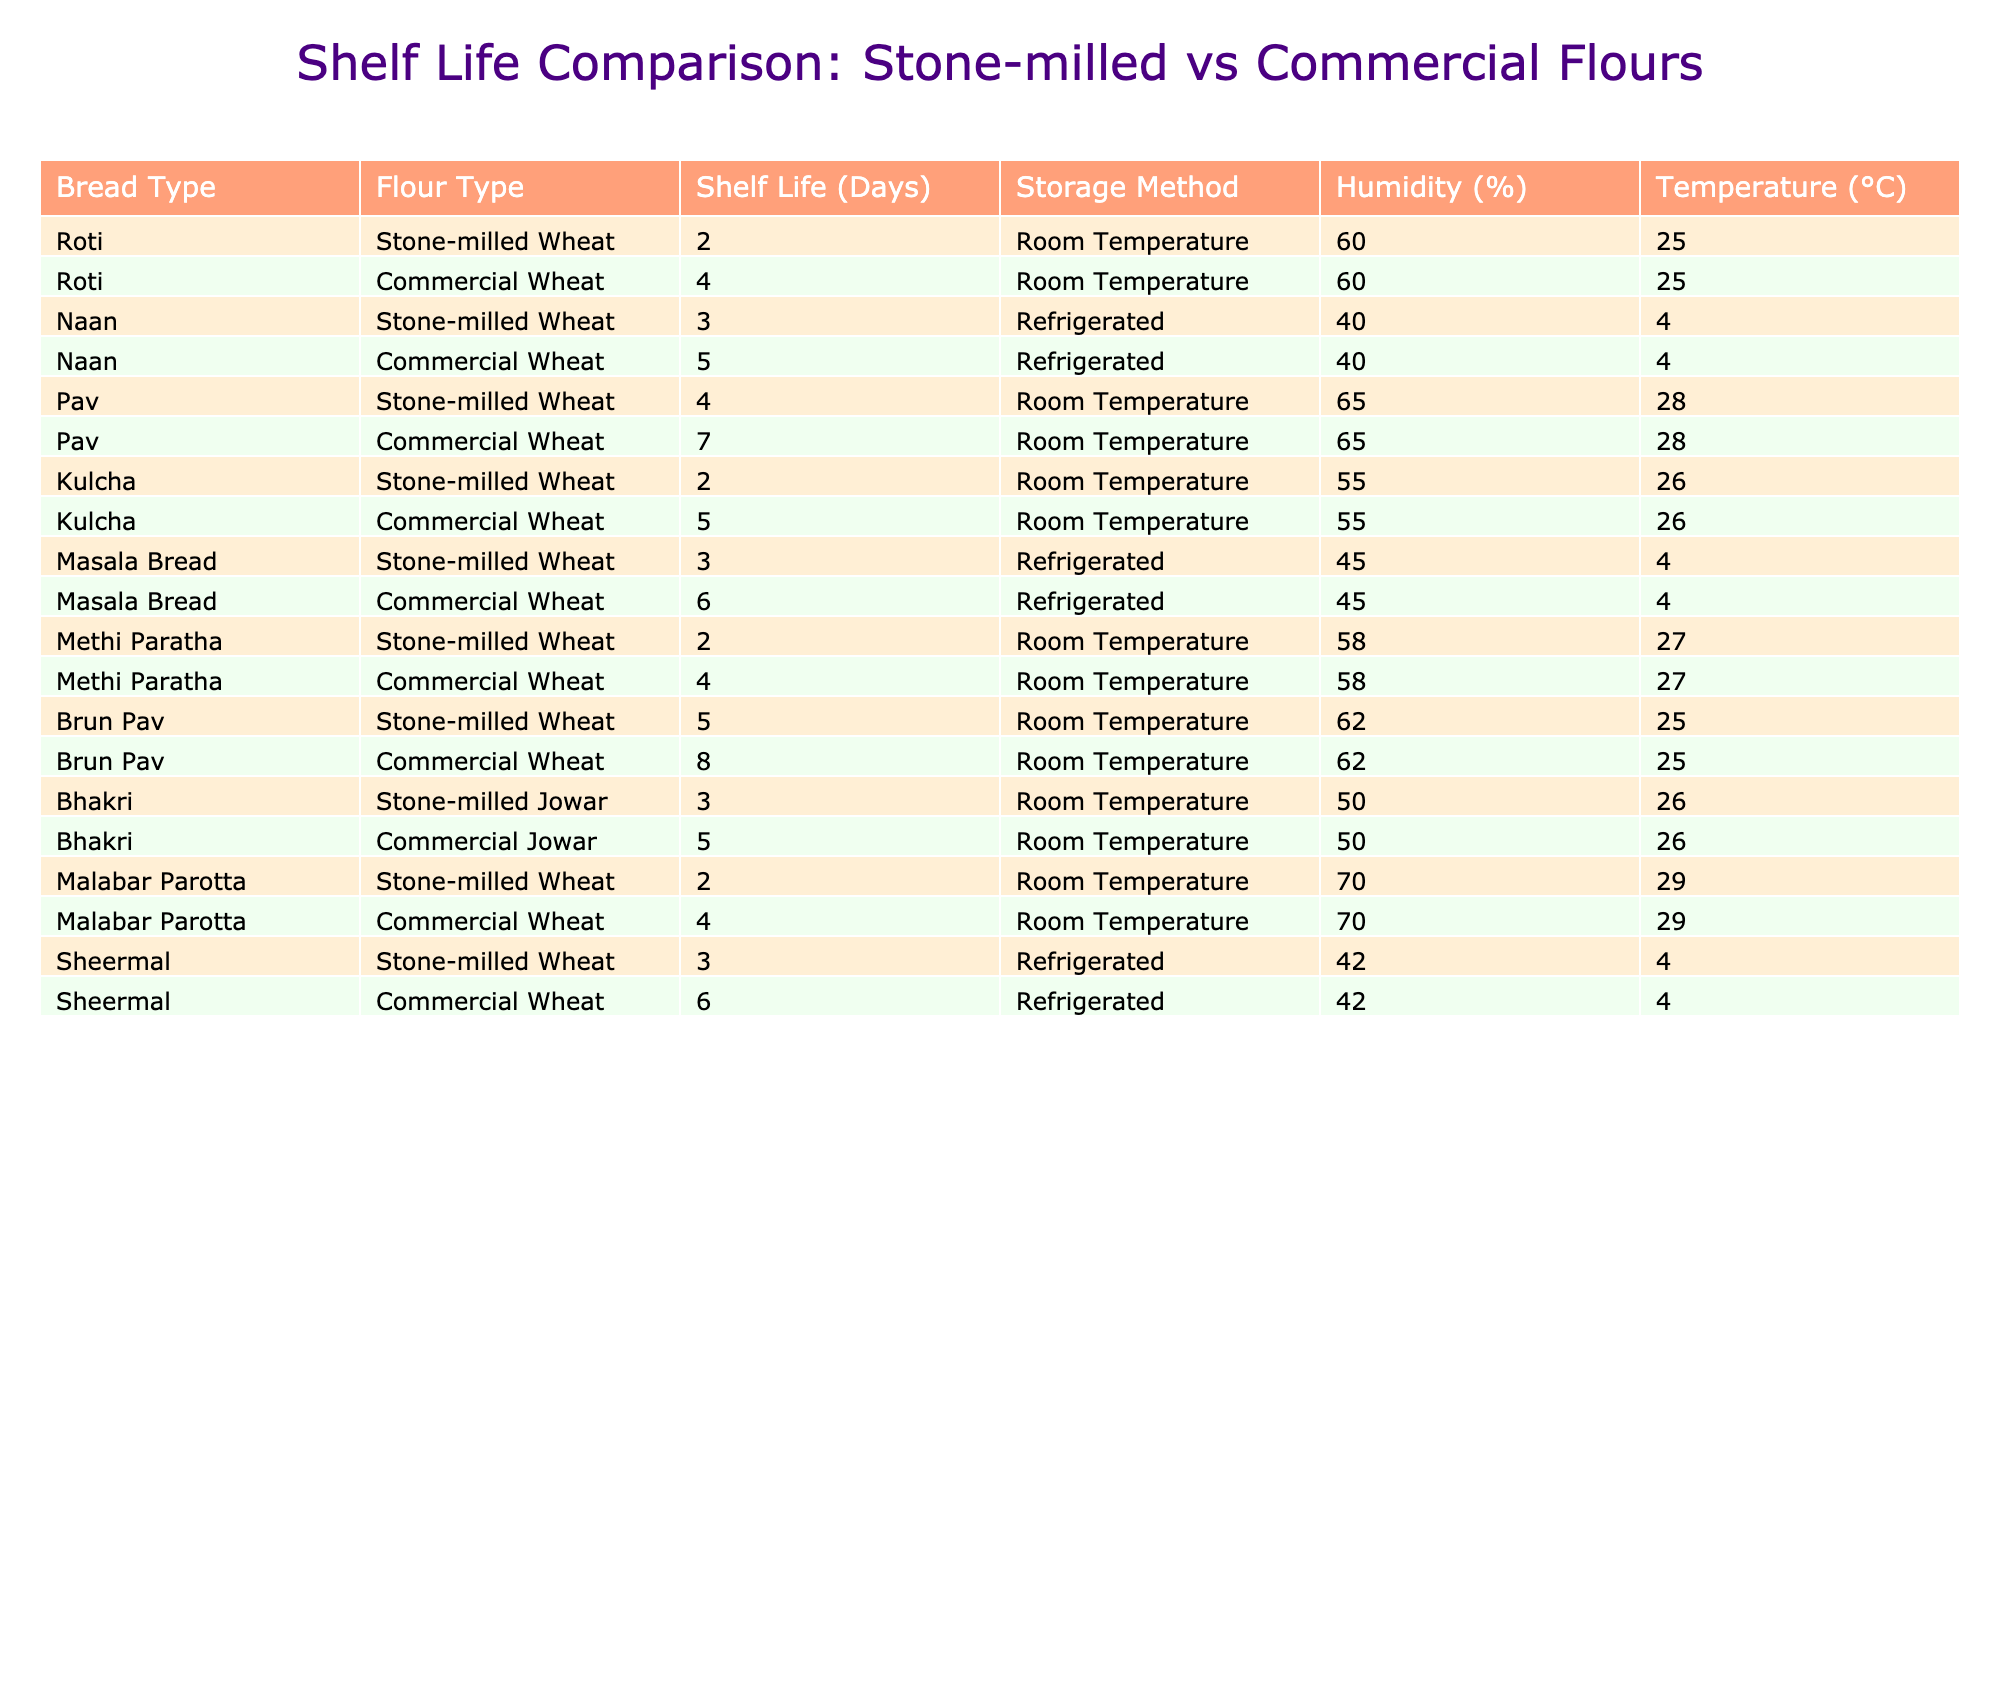What is the shelf life of Roti made with stone-milled flour? From the table, the shelf life of Roti made with stone-milled flour is listed as 2 days.
Answer: 2 days What is the shelf life difference for Naan made with stone-milled vs commercial flour? The shelf life of Naan made with stone-milled flour is 3 days, while for commercial flour, it is 5 days. The difference is 5 - 3 = 2 days.
Answer: 2 days Is the shelf life of Pav made with stone-milled flour longer than that made with commercial flour? The shelf life of Pav made with stone-milled flour is 4 days, and for commercial flour, it is 7 days. Since 4 is not greater than 7, the statement is false.
Answer: No What type of flour allows for the longest shelf life for Brun Pav? The table shows Brun Pav has a shelf life of 5 days with stone-milled flour and 8 days with commercial flour. Therefore, commercial flour allows for the longest shelf life.
Answer: Commercial flour How many types of bread have a shelf life of 2 days or less? From the table, the breads with a shelf life of 2 days or less are Roti, Kulcha, and Malabar Parotta, totaling 3 types.
Answer: 3 types For Masala Bread, how much longer can the commercial version be stored compared to the stone-milled version? The shelf life for Masala Bread made with stone-milled flour is 3 days, while for commercial flour, it is 6 days. The difference is 6 - 3 = 3 days.
Answer: 3 days Which storage method tends to provide a longer shelf life for breads made with stone-milled flour? By analyzing the table, breads stored in refrigerated conditions generally have longer shelf lives. For instance, Naan (3 days) and Sheermal (3 days) when refrigerated have better longevity compared to those stored at room temperature.
Answer: Refrigerated storage Does any bread made with stone-milled flour have a shelf life of more than 5 days? Checking the table, all breads made with stone-milled flour have a maximum shelf life of 5 days, while the longest is Brun Pav at 5 days. Hence, no bread exceeds this shelf life.
Answer: No What is the average shelf life for all types of breads made with stone-milled wheat? Summing the shelf lives (2 + 3 + 4 + 2 + 3 + 2 + 5 = 21) gives 21 days. There are 7 data points, so the average is 21 / 7 = 3 days.
Answer: 3 days 